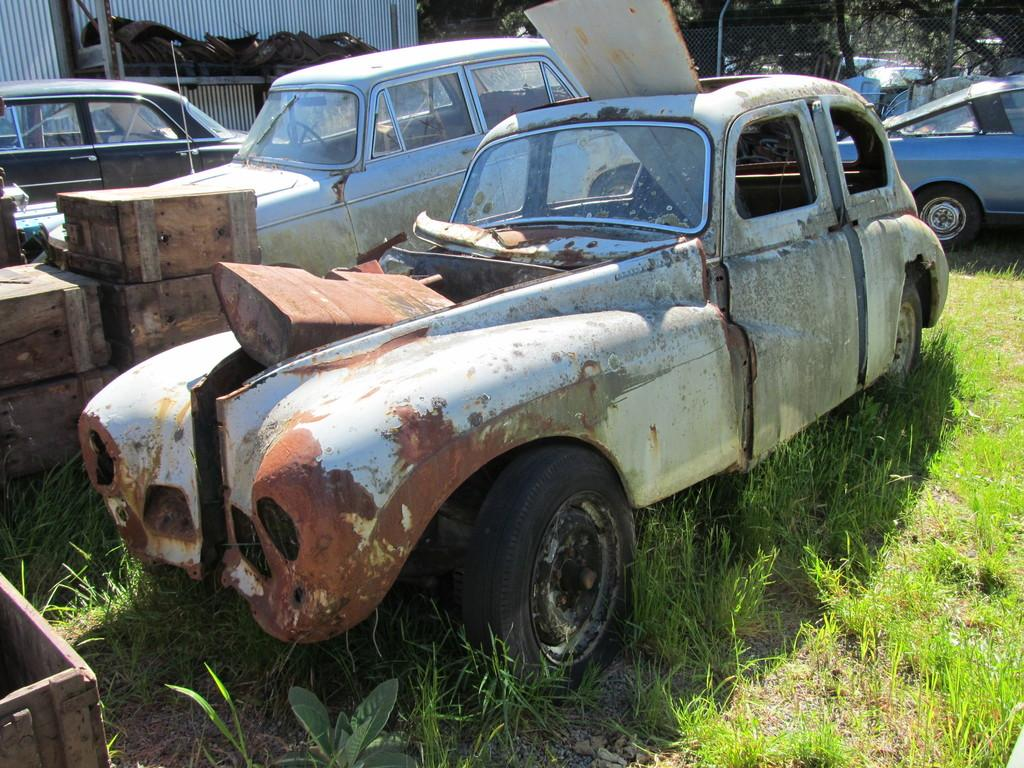What type of vehicles can be seen in the image? There are old cars in the image. What else is present on the ground in the image? There are other objects on the ground in the image. How is the ground depicted in the image? The ground is covered in greenery. What can be seen in the background of the image? There are trees in the background of the image. What type of flowers can be seen in the park in the image? There is no park or flowers present in the image; it features old cars and other objects on the ground. How are people transported to their destinations in the image? The image does not show any transportation methods for people; it only features old cars. 